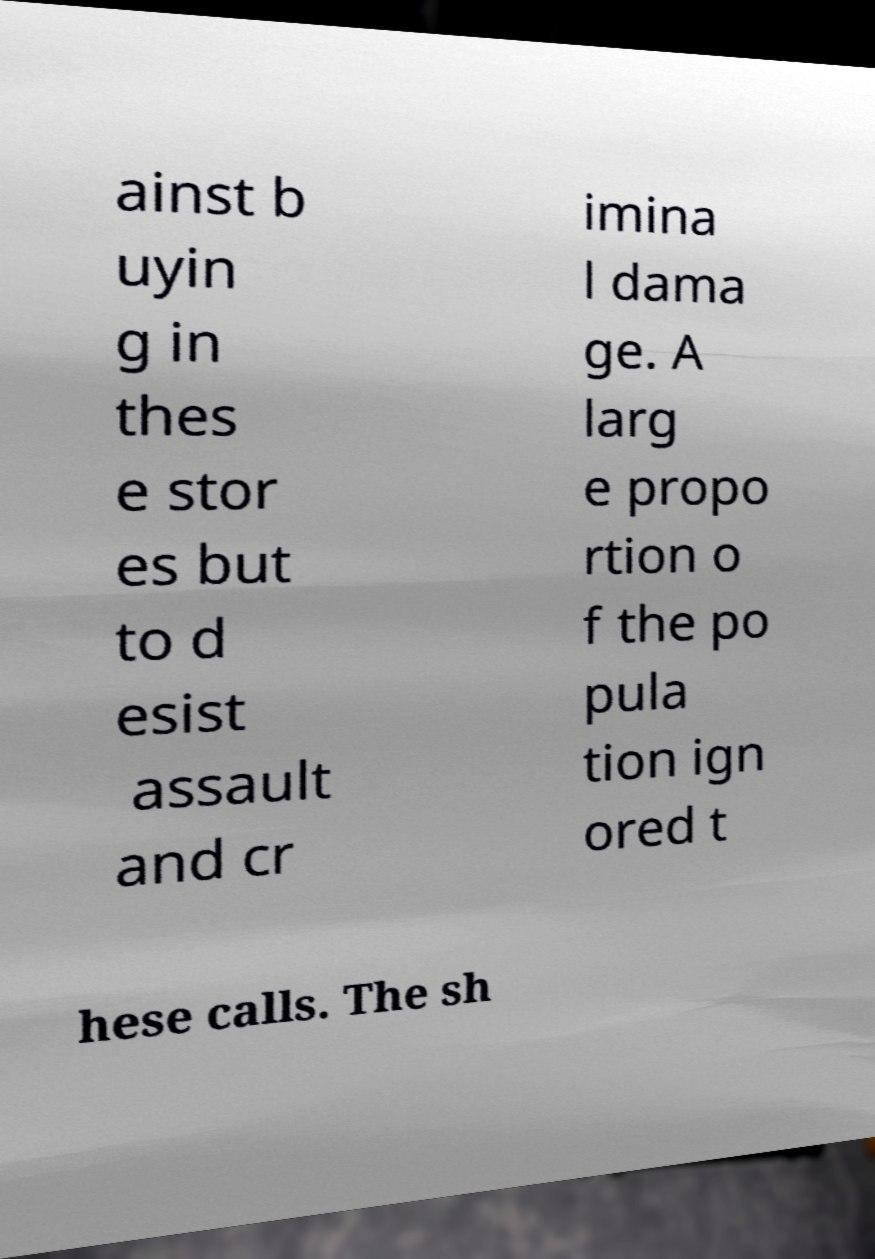For documentation purposes, I need the text within this image transcribed. Could you provide that? ainst b uyin g in thes e stor es but to d esist assault and cr imina l dama ge. A larg e propo rtion o f the po pula tion ign ored t hese calls. The sh 